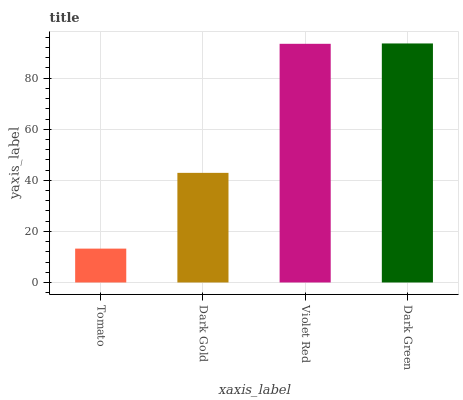Is Dark Gold the minimum?
Answer yes or no. No. Is Dark Gold the maximum?
Answer yes or no. No. Is Dark Gold greater than Tomato?
Answer yes or no. Yes. Is Tomato less than Dark Gold?
Answer yes or no. Yes. Is Tomato greater than Dark Gold?
Answer yes or no. No. Is Dark Gold less than Tomato?
Answer yes or no. No. Is Violet Red the high median?
Answer yes or no. Yes. Is Dark Gold the low median?
Answer yes or no. Yes. Is Dark Green the high median?
Answer yes or no. No. Is Violet Red the low median?
Answer yes or no. No. 